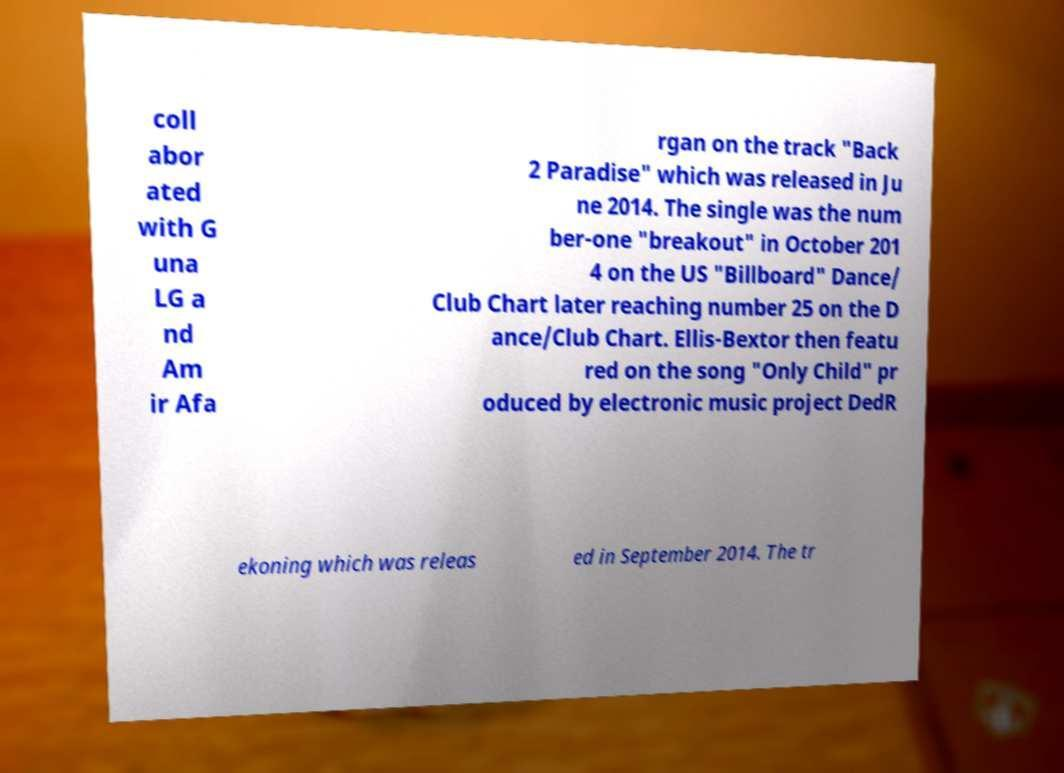I need the written content from this picture converted into text. Can you do that? coll abor ated with G una LG a nd Am ir Afa rgan on the track "Back 2 Paradise" which was released in Ju ne 2014. The single was the num ber-one "breakout" in October 201 4 on the US "Billboard" Dance/ Club Chart later reaching number 25 on the D ance/Club Chart. Ellis-Bextor then featu red on the song "Only Child" pr oduced by electronic music project DedR ekoning which was releas ed in September 2014. The tr 